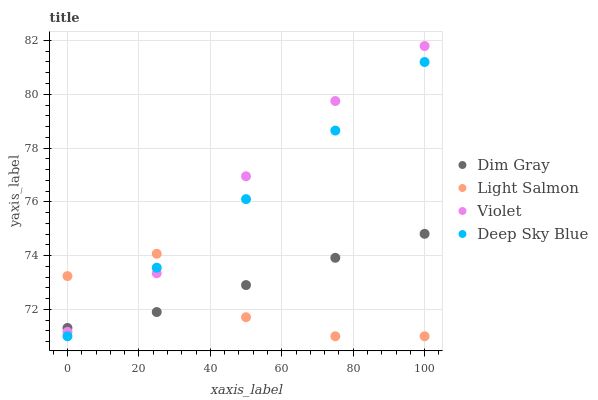Does Light Salmon have the minimum area under the curve?
Answer yes or no. Yes. Does Violet have the maximum area under the curve?
Answer yes or no. Yes. Does Dim Gray have the minimum area under the curve?
Answer yes or no. No. Does Dim Gray have the maximum area under the curve?
Answer yes or no. No. Is Deep Sky Blue the smoothest?
Answer yes or no. Yes. Is Light Salmon the roughest?
Answer yes or no. Yes. Is Dim Gray the smoothest?
Answer yes or no. No. Is Dim Gray the roughest?
Answer yes or no. No. Does Light Salmon have the lowest value?
Answer yes or no. Yes. Does Dim Gray have the lowest value?
Answer yes or no. No. Does Violet have the highest value?
Answer yes or no. Yes. Does Dim Gray have the highest value?
Answer yes or no. No. Does Light Salmon intersect Violet?
Answer yes or no. Yes. Is Light Salmon less than Violet?
Answer yes or no. No. Is Light Salmon greater than Violet?
Answer yes or no. No. 